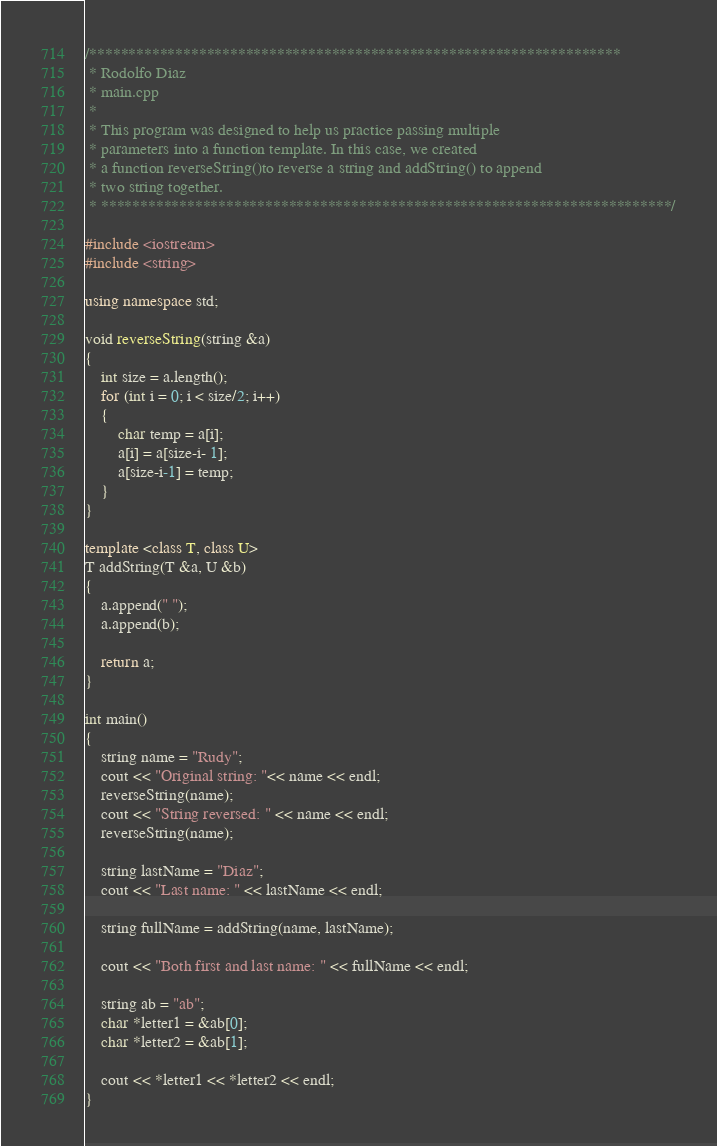<code> <loc_0><loc_0><loc_500><loc_500><_C++_>/********************************************************************
 * Rodolfo Diaz
 * main.cpp
 * 
 * This program was designed to help us practice passing multiple 
 * parameters into a function template. In this case, we created 
 * a function reverseString()to reverse a string and addString() to append
 * two string together.
 * *************************************************************************/

#include <iostream>
#include <string>

using namespace std;

void reverseString(string &a)
{
    int size = a.length();
    for (int i = 0; i < size/2; i++)
    {
        char temp = a[i];
        a[i] = a[size-i- 1];
        a[size-i-1] = temp;
    }
}

template <class T, class U>
T addString(T &a, U &b)
{
    a.append(" ");
    a.append(b);
    
    return a;
}

int main()
{
    string name = "Rudy";
    cout << "Original string: "<< name << endl;
    reverseString(name);
    cout << "String reversed: " << name << endl;
    reverseString(name);
    
    string lastName = "Diaz";
    cout << "Last name: " << lastName << endl;
    
    string fullName = addString(name, lastName);
    
    cout << "Both first and last name: " << fullName << endl;
    
    string ab = "ab";
    char *letter1 = &ab[0];
    char *letter2 = &ab[1];
    
    cout << *letter1 << *letter2 << endl;
}</code> 